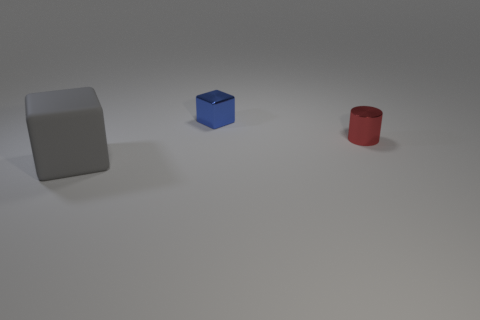Add 2 large green cubes. How many objects exist? 5 Subtract all cubes. How many objects are left? 1 Subtract all cyan cylinders. Subtract all blue cubes. How many cylinders are left? 1 Subtract all large objects. Subtract all red shiny cylinders. How many objects are left? 1 Add 2 red shiny cylinders. How many red shiny cylinders are left? 3 Add 2 small blue shiny objects. How many small blue shiny objects exist? 3 Subtract 0 purple cubes. How many objects are left? 3 